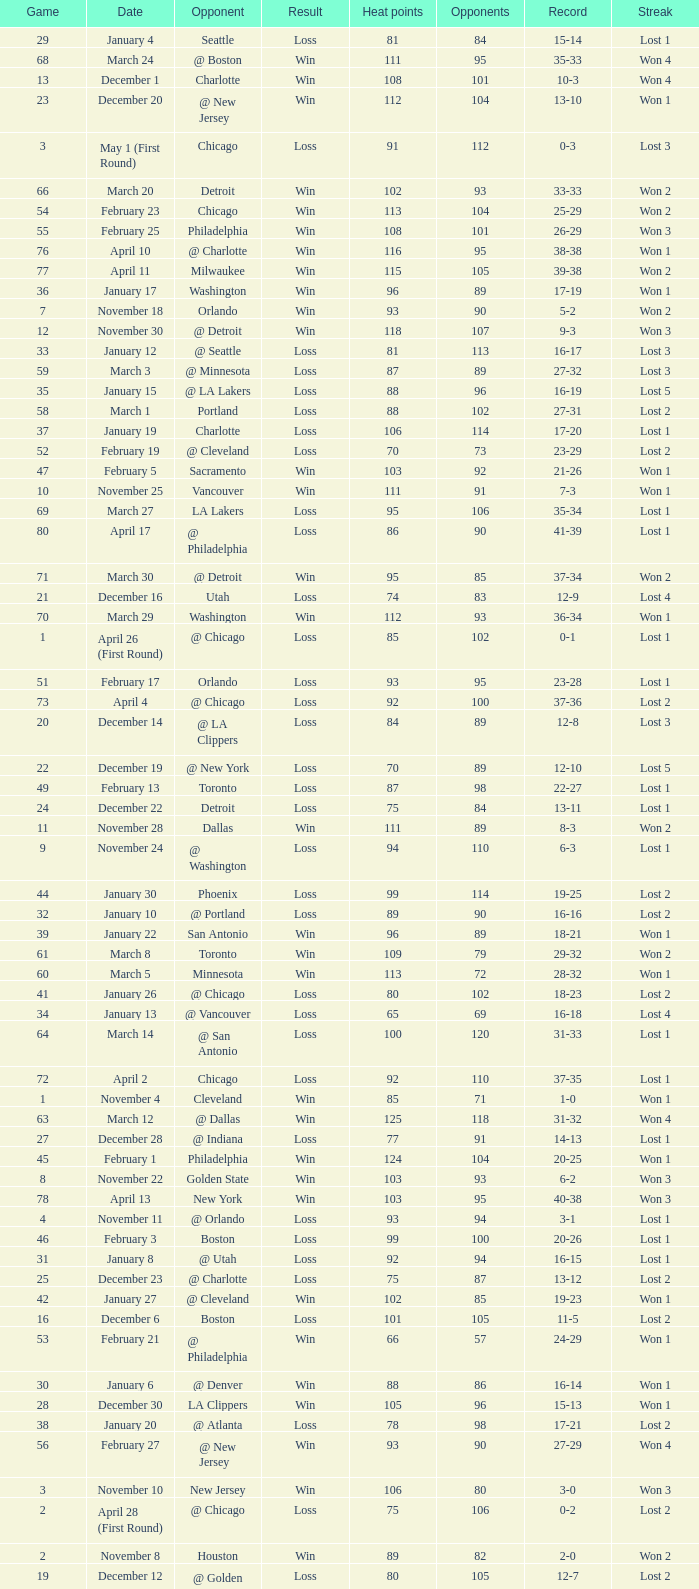What is Heat Points, when Game is less than 80, and when Date is "April 26 (First Round)"? 85.0. 